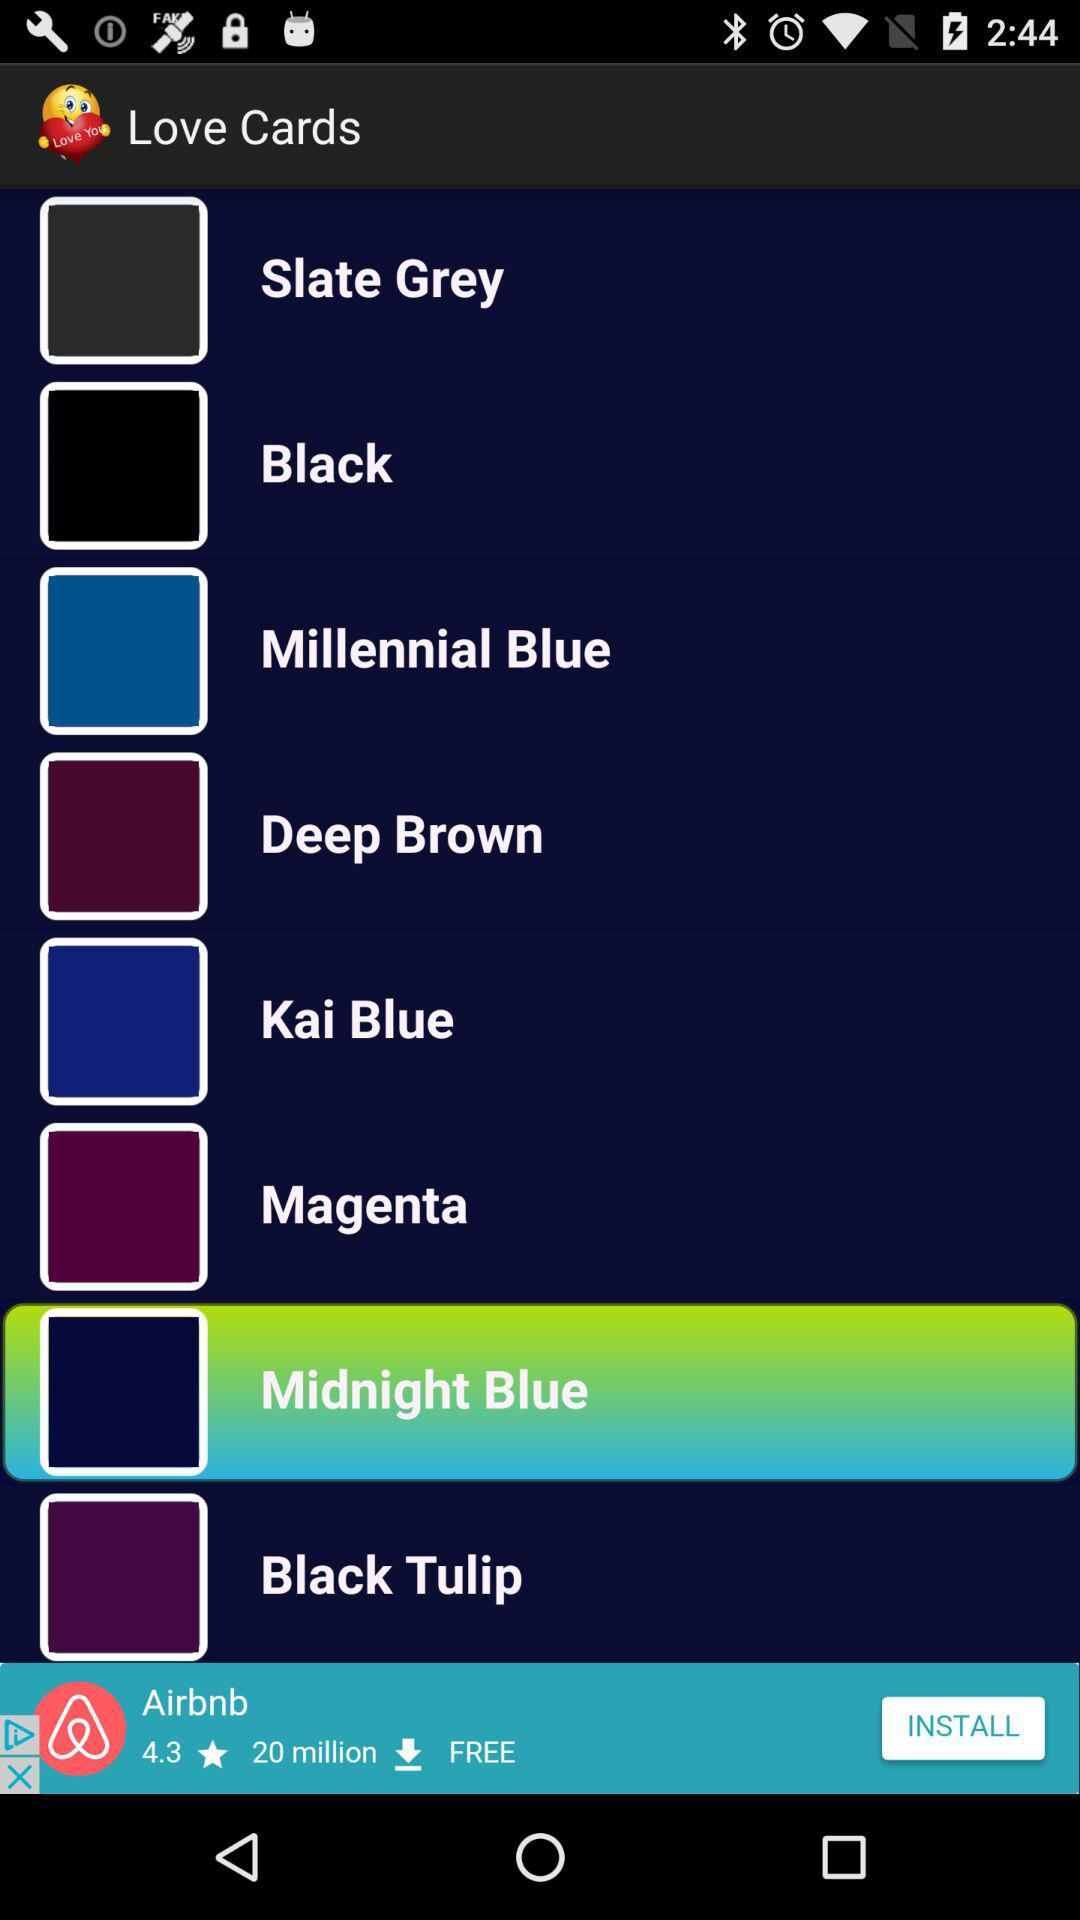What are the available colors in "Love Cards"? The available colors are Slate Grey, Black, Millennial Blue, Deep Brown, Kai Blue, Magenta, Midnight Blue and Black Tulip. 